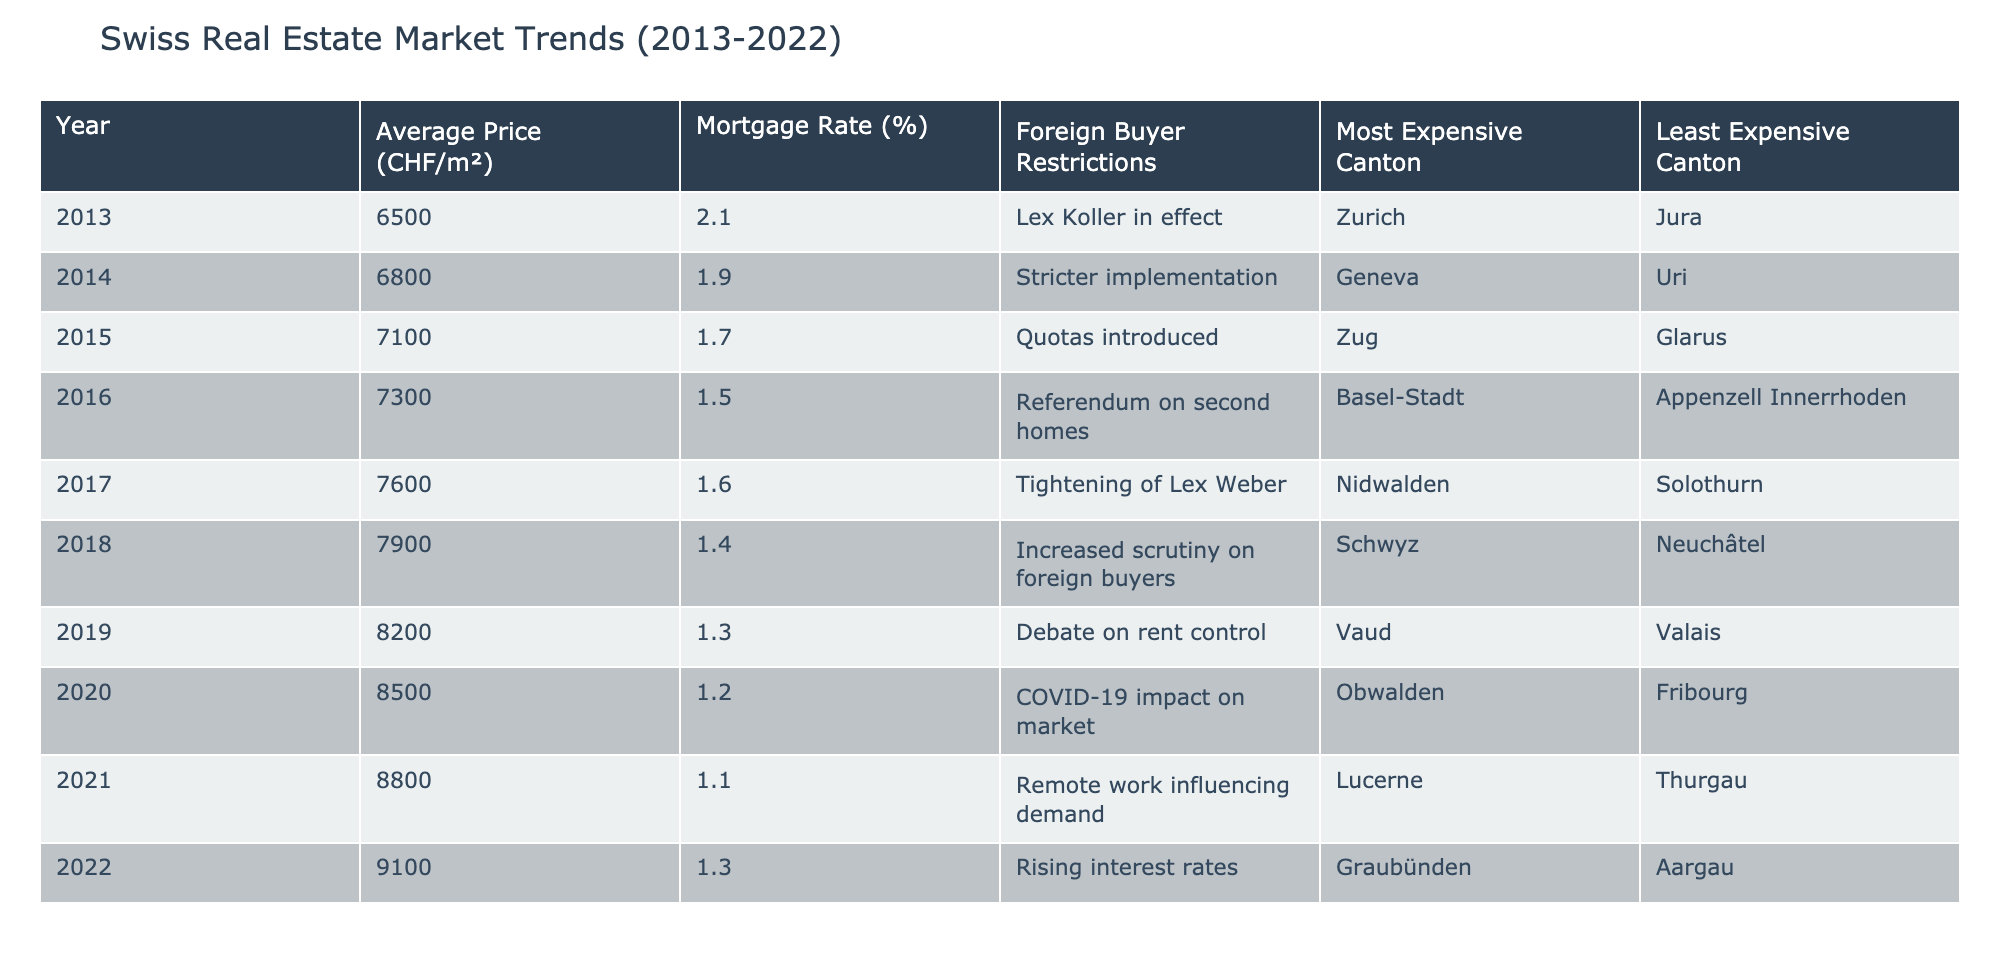What was the average price per square meter in 2020? In the table, we locate the row for the year 2020 and find the value under the "Average Price (CHF/m²)" column. The average price in 2020 is 8500 CHF/m².
Answer: 8500 CHF/m² Which year recorded the lowest mortgage rate? The table shows the "Mortgage Rate (%)" for each year. By examining the values, the lowest rate is 1.1% in 2021.
Answer: 1.1% Which canton was the most expensive in 2019? We look at the row for 2019 to find the "Most Expensive Canton" column. It indicates that in 2019, the most expensive canton was Vaud.
Answer: Vaud Did the average price of real estate increase every year from 2013 to 2022? By checking each year's average price, we see that it increased consecutively: 6500, 6800, 7100, 7300, 7600, 7900, 8200, 8500, 8800, and 9100 CHF/m². Thus, it increased every year.
Answer: Yes What is the difference in average price per square meter between the years 2013 and 2022? The average price in 2013 was 6500 CHF/m² and in 2022 it was 9100 CHF/m². To find the difference, we subtract: 9100 - 6500 = 2600 CHF/m².
Answer: 2600 CHF/m² How many years had foreign buyer restrictions in effect? By reviewing the "Foreign Buyer Restrictions" column, we see that all years from 2013 to 2022 mentioned restrictions in different forms. Hence, there are 10 years total.
Answer: 10 years In which canton was the least expensive property found in 2018? Referring to the year 2018 in the table, we check the "Least Expensive Canton" column and find that it is Neuchâtel.
Answer: Neuchâtel Was the mortgage rate the same or lower in 2022 compared to 2013? The mortgage rate in 2022 is 1.3%, while in 2013 it was 2.1%. Since 1.3% is lower than 2.1%, the answer is yes.
Answer: Yes Which canton saw a tightening of restrictions in 2017? Checking the "Foreign Buyer Restrictions" for 2017 indicates that there was a tightening of Lex Weber, but it doesn't specify a particular canton. However, we find that the most expensive canton that year is Nidwalden.
Answer: Nidwalden 